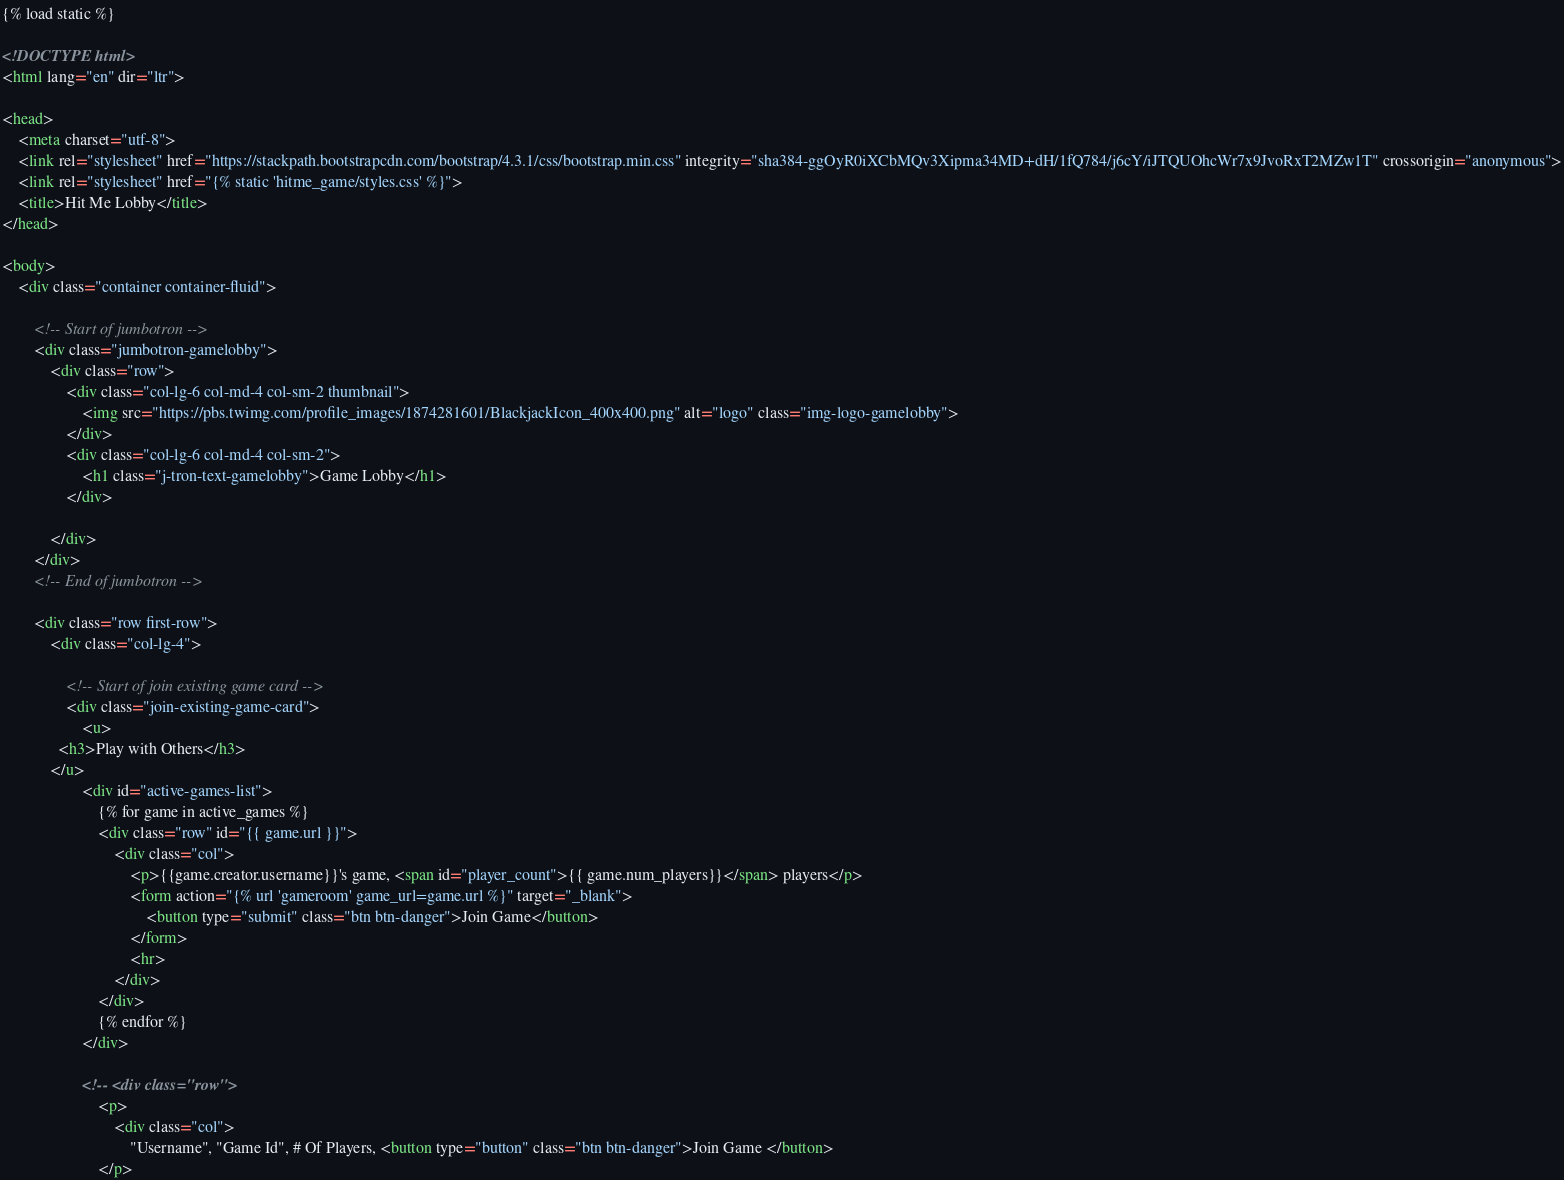Convert code to text. <code><loc_0><loc_0><loc_500><loc_500><_HTML_>{% load static %}

<!DOCTYPE html>
<html lang="en" dir="ltr">

<head>
    <meta charset="utf-8">
    <link rel="stylesheet" href="https://stackpath.bootstrapcdn.com/bootstrap/4.3.1/css/bootstrap.min.css" integrity="sha384-ggOyR0iXCbMQv3Xipma34MD+dH/1fQ784/j6cY/iJTQUOhcWr7x9JvoRxT2MZw1T" crossorigin="anonymous">
    <link rel="stylesheet" href="{% static 'hitme_game/styles.css' %}">
    <title>Hit Me Lobby</title>
</head>

<body>
    <div class="container container-fluid">

        <!-- Start of jumbotron -->
        <div class="jumbotron-gamelobby">
            <div class="row">
                <div class="col-lg-6 col-md-4 col-sm-2 thumbnail">
                    <img src="https://pbs.twimg.com/profile_images/1874281601/BlackjackIcon_400x400.png" alt="logo" class="img-logo-gamelobby">
                </div>
                <div class="col-lg-6 col-md-4 col-sm-2">
                    <h1 class="j-tron-text-gamelobby">Game Lobby</h1>
                </div>

            </div>
        </div>
        <!-- End of jumbotron -->

        <div class="row first-row">
            <div class="col-lg-4">

                <!-- Start of join existing game card -->
                <div class="join-existing-game-card">
                    <u>
              <h3>Play with Others</h3>
            </u>
                    <div id="active-games-list">
                        {% for game in active_games %}
                        <div class="row" id="{{ game.url }}">
                            <div class="col">
                                <p>{{game.creator.username}}'s game, <span id="player_count">{{ game.num_players}}</span> players</p>
                                <form action="{% url 'gameroom' game_url=game.url %}" target="_blank">
                                    <button type="submit" class="btn btn-danger">Join Game</button>
                                </form>
                                <hr>
                            </div>
                        </div>
                        {% endfor %}
                    </div>

                    <!-- <div class="row">
                        <p>
                            <div class="col">
                                "Username", "Game Id", # Of Players, <button type="button" class="btn btn-danger">Join Game </button>
                        </p></code> 